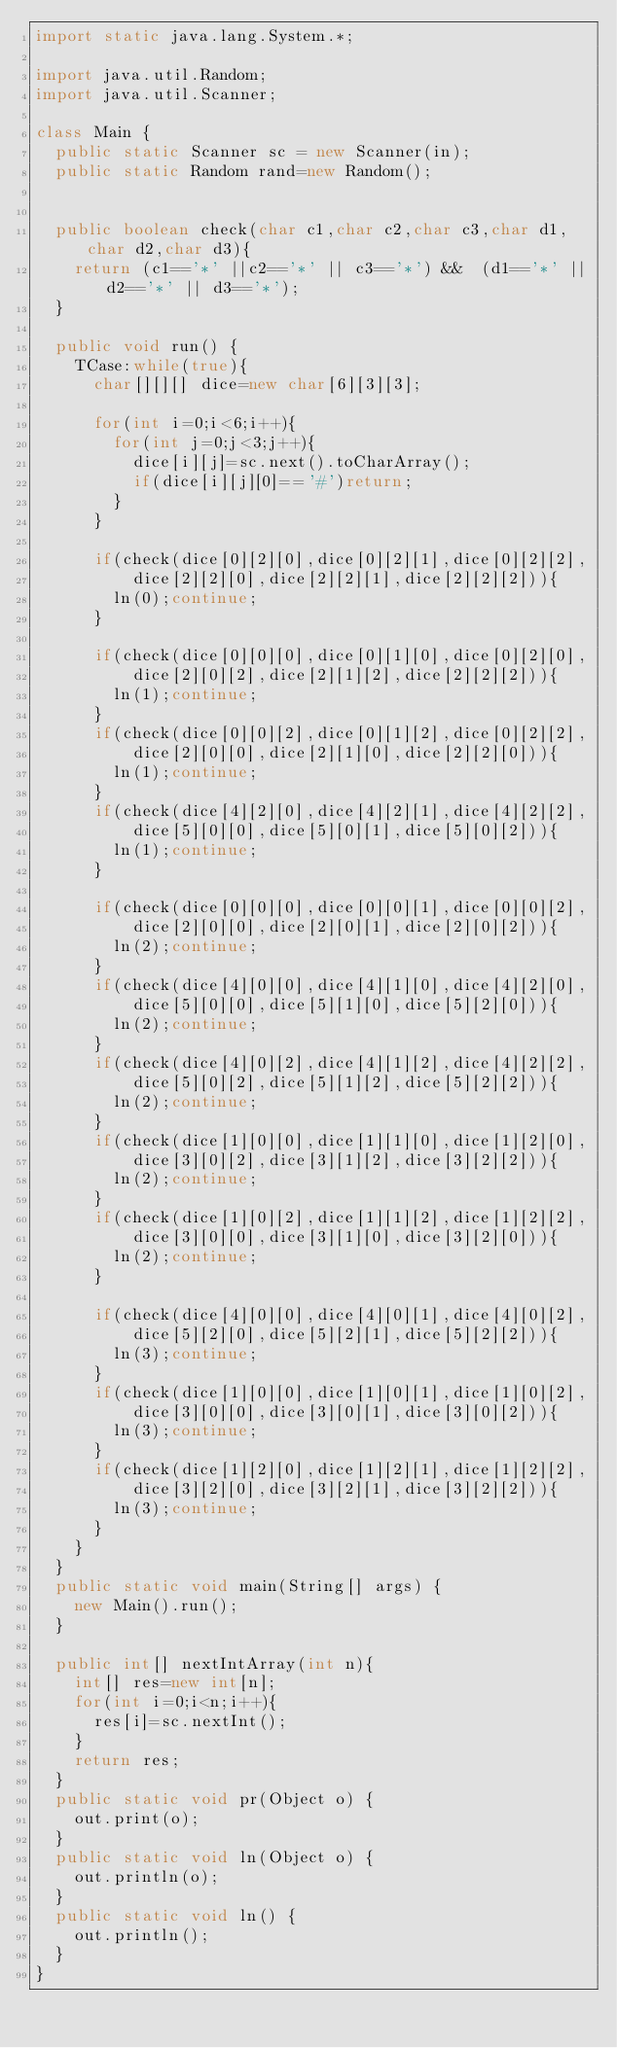Convert code to text. <code><loc_0><loc_0><loc_500><loc_500><_Java_>import static java.lang.System.*;

import java.util.Random;
import java.util.Scanner;

class Main {
	public static Scanner sc = new Scanner(in);
	public static Random rand=new Random();


	public boolean check(char c1,char c2,char c3,char d1,char d2,char d3){
		return (c1=='*' ||c2=='*' || c3=='*') &&  (d1=='*' ||d2=='*' || d3=='*');
	}

	public void run() {
		TCase:while(true){
			char[][][] dice=new char[6][3][3];

			for(int i=0;i<6;i++){
				for(int j=0;j<3;j++){
					dice[i][j]=sc.next().toCharArray();
					if(dice[i][j][0]=='#')return;
				}
			}

			if(check(dice[0][2][0],dice[0][2][1],dice[0][2][2],
					dice[2][2][0],dice[2][2][1],dice[2][2][2])){
				ln(0);continue;
			}

			if(check(dice[0][0][0],dice[0][1][0],dice[0][2][0],
					dice[2][0][2],dice[2][1][2],dice[2][2][2])){
				ln(1);continue;
			}
			if(check(dice[0][0][2],dice[0][1][2],dice[0][2][2],
					dice[2][0][0],dice[2][1][0],dice[2][2][0])){
				ln(1);continue;
			}
			if(check(dice[4][2][0],dice[4][2][1],dice[4][2][2],
					dice[5][0][0],dice[5][0][1],dice[5][0][2])){
				ln(1);continue;
			}

			if(check(dice[0][0][0],dice[0][0][1],dice[0][0][2],
					dice[2][0][0],dice[2][0][1],dice[2][0][2])){
				ln(2);continue;
			}
			if(check(dice[4][0][0],dice[4][1][0],dice[4][2][0],
					dice[5][0][0],dice[5][1][0],dice[5][2][0])){
				ln(2);continue;
			}
			if(check(dice[4][0][2],dice[4][1][2],dice[4][2][2],
					dice[5][0][2],dice[5][1][2],dice[5][2][2])){
				ln(2);continue;
			}
			if(check(dice[1][0][0],dice[1][1][0],dice[1][2][0],
					dice[3][0][2],dice[3][1][2],dice[3][2][2])){
				ln(2);continue;
			}
			if(check(dice[1][0][2],dice[1][1][2],dice[1][2][2],
					dice[3][0][0],dice[3][1][0],dice[3][2][0])){
				ln(2);continue;
			}

			if(check(dice[4][0][0],dice[4][0][1],dice[4][0][2],
					dice[5][2][0],dice[5][2][1],dice[5][2][2])){
				ln(3);continue;
			}
			if(check(dice[1][0][0],dice[1][0][1],dice[1][0][2],
					dice[3][0][0],dice[3][0][1],dice[3][0][2])){
				ln(3);continue;
			}
			if(check(dice[1][2][0],dice[1][2][1],dice[1][2][2],
					dice[3][2][0],dice[3][2][1],dice[3][2][2])){
				ln(3);continue;
			}
		}
	}
	public static void main(String[] args) {
		new Main().run();
	}

	public int[] nextIntArray(int n){
		int[] res=new int[n];
		for(int i=0;i<n;i++){
			res[i]=sc.nextInt();
		}
		return res;
	}
	public static void pr(Object o) {
		out.print(o);
	}
	public static void ln(Object o) {
		out.println(o);
	}
	public static void ln() {
		out.println();
	}
}</code> 